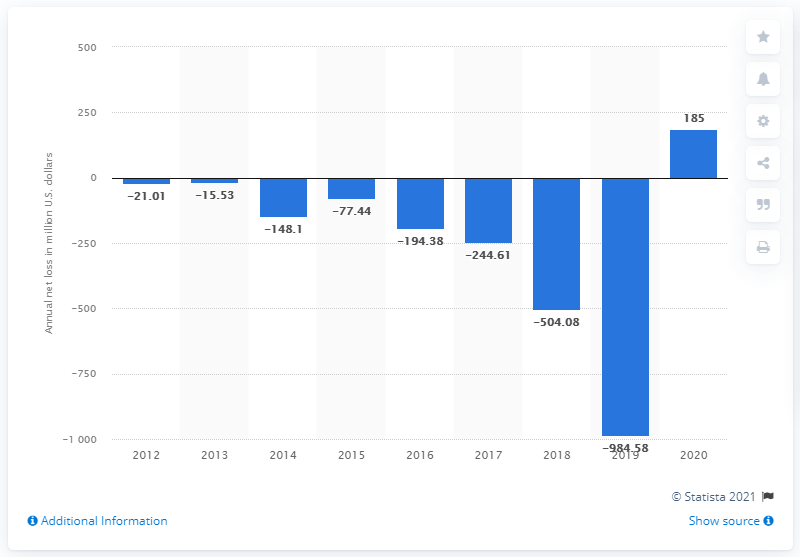Mention a couple of crucial points in this snapshot. In the year 2020, Wayfair's net income was $185 million. 